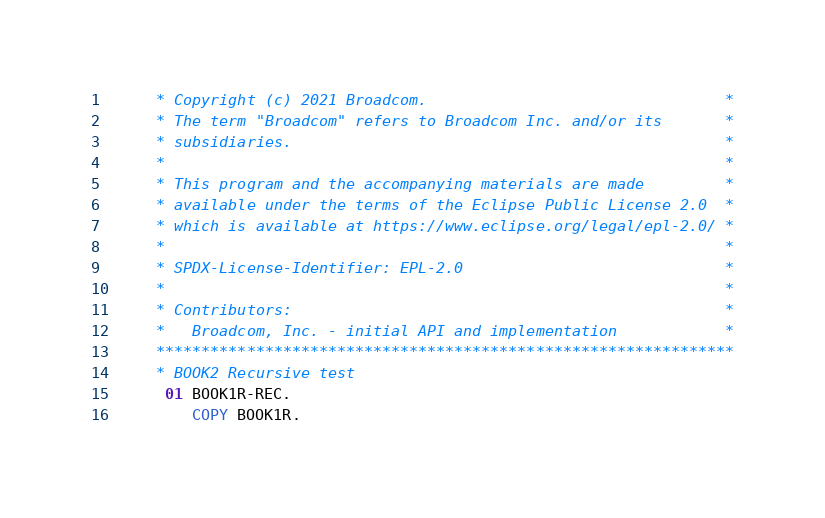<code> <loc_0><loc_0><loc_500><loc_500><_COBOL_>      * Copyright (c) 2021 Broadcom.                                 *
      * The term "Broadcom" refers to Broadcom Inc. and/or its       *
      * subsidiaries.                                                *
      *                                                              *
      * This program and the accompanying materials are made         *
      * available under the terms of the Eclipse Public License 2.0  *
      * which is available at https://www.eclipse.org/legal/epl-2.0/ *
      *                                                              *
      * SPDX-License-Identifier: EPL-2.0                             *
      *                                                              *
      * Contributors:                                                *
      *   Broadcom, Inc. - initial API and implementation            *
      ****************************************************************
      * BOOK2 Recursive test
       01 BOOK1R-REC.
          COPY BOOK1R.</code> 